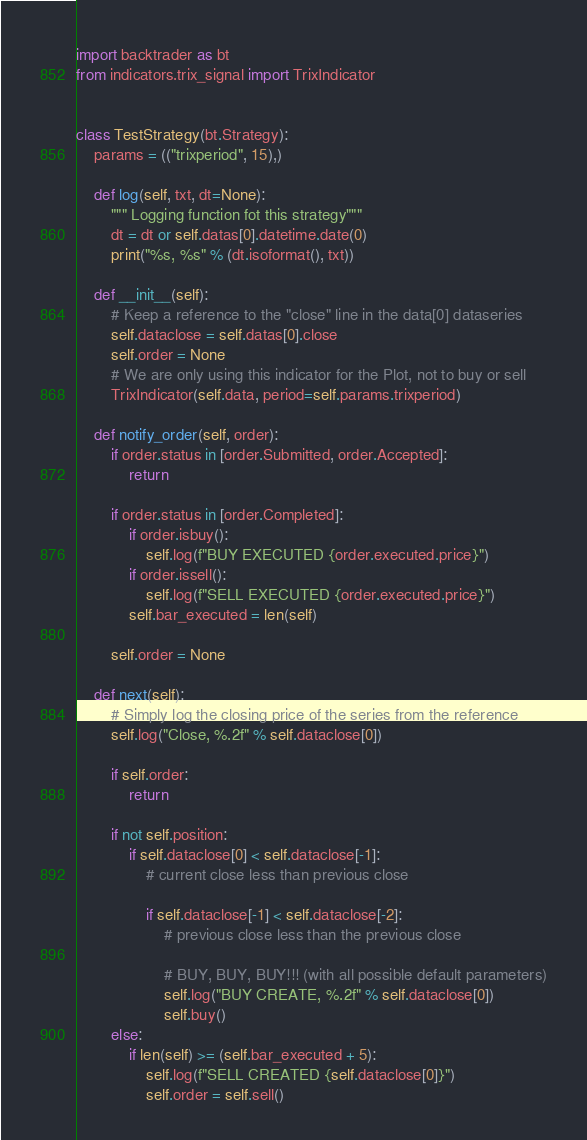<code> <loc_0><loc_0><loc_500><loc_500><_Python_>import backtrader as bt
from indicators.trix_signal import TrixIndicator


class TestStrategy(bt.Strategy):
    params = (("trixperiod", 15),)

    def log(self, txt, dt=None):
        """ Logging function fot this strategy"""
        dt = dt or self.datas[0].datetime.date(0)
        print("%s, %s" % (dt.isoformat(), txt))

    def __init__(self):
        # Keep a reference to the "close" line in the data[0] dataseries
        self.dataclose = self.datas[0].close
        self.order = None
        # We are only using this indicator for the Plot, not to buy or sell
        TrixIndicator(self.data, period=self.params.trixperiod)

    def notify_order(self, order):
        if order.status in [order.Submitted, order.Accepted]:
            return

        if order.status in [order.Completed]:
            if order.isbuy():
                self.log(f"BUY EXECUTED {order.executed.price}")
            if order.issell():
                self.log(f"SELL EXECUTED {order.executed.price}")
            self.bar_executed = len(self)

        self.order = None

    def next(self):
        # Simply log the closing price of the series from the reference
        self.log("Close, %.2f" % self.dataclose[0])

        if self.order:
            return

        if not self.position:
            if self.dataclose[0] < self.dataclose[-1]:
                # current close less than previous close

                if self.dataclose[-1] < self.dataclose[-2]:
                    # previous close less than the previous close

                    # BUY, BUY, BUY!!! (with all possible default parameters)
                    self.log("BUY CREATE, %.2f" % self.dataclose[0])
                    self.buy()
        else:
            if len(self) >= (self.bar_executed + 5):
                self.log(f"SELL CREATED {self.dataclose[0]}")
                self.order = self.sell()
</code> 